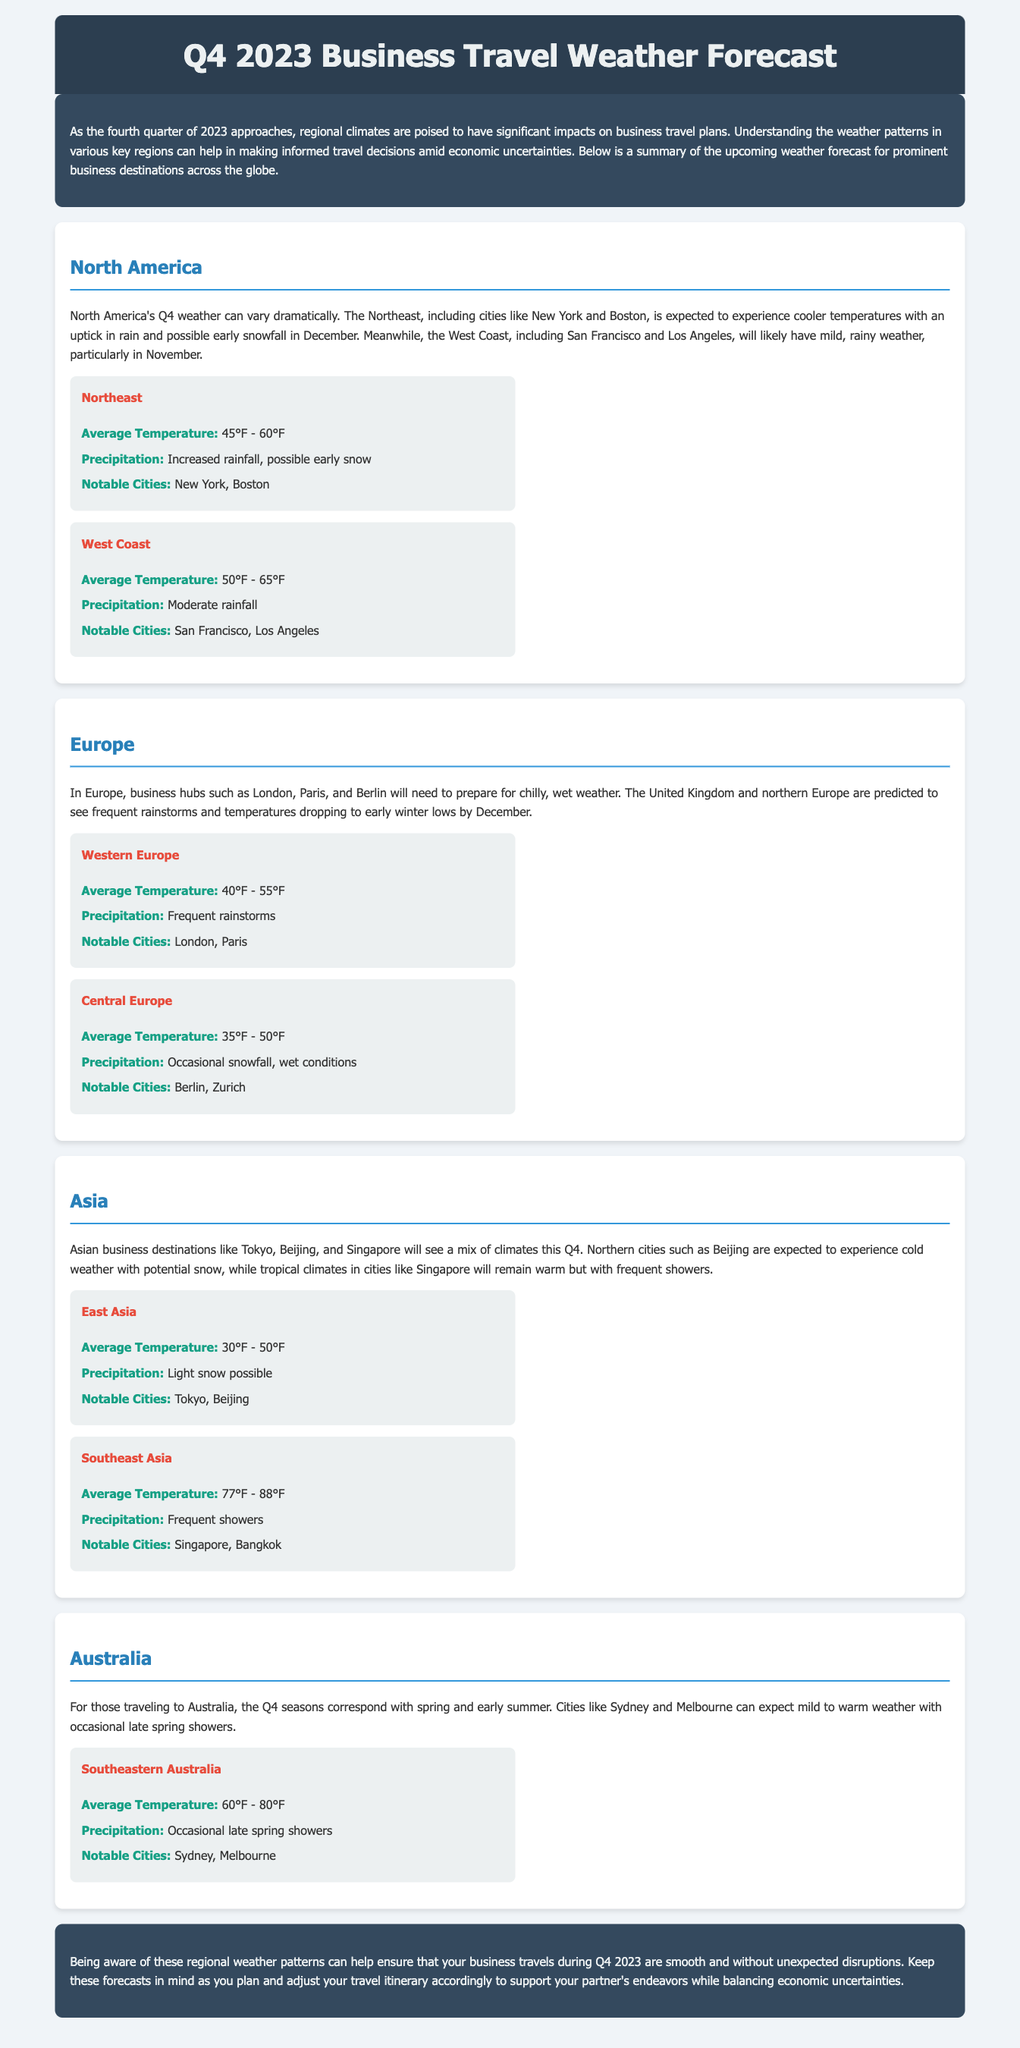What is the average temperature range for the Northeast region? The document specifies that the average temperature for the Northeast is between 45°F and 60°F.
Answer: 45°F - 60°F What notable cities are mentioned in the West Coast forecast? According to the document, notable cities in the West Coast include San Francisco and Los Angeles.
Answer: San Francisco, Los Angeles What type of precipitation is expected in Central Europe? The document indicates that Central Europe is expected to have occasional snowfall and wet conditions.
Answer: Occasional snowfall, wet conditions What is the predominant climate in Southeast Asia during Q4? The forecast for Southeast Asia indicates that the climate will be warm with frequent showers.
Answer: Warm, frequent showers What is the average temperature range for the Southeastern Australia region? The document notes that the average temperature for Southeastern Australia is between 60°F and 80°F.
Answer: 60°F - 80°F How will the weather in Northern cities of Asia like Beijing be in Q4? The document states that Northern cities such as Beijing are expected to experience cold weather with potential snow.
Answer: Cold weather, potential snow What is the expected weather condition for business hubs in Western Europe? The document mentions that business hubs in Western Europe will need to prepare for chilly, wet weather.
Answer: Chilly, wet weather What is the economic context mentioned in the introduction of the document? The introduction states that understanding weather patterns can help make informed travel decisions amid economic uncertainties.
Answer: Economic uncertainties 